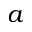<formula> <loc_0><loc_0><loc_500><loc_500>a</formula> 